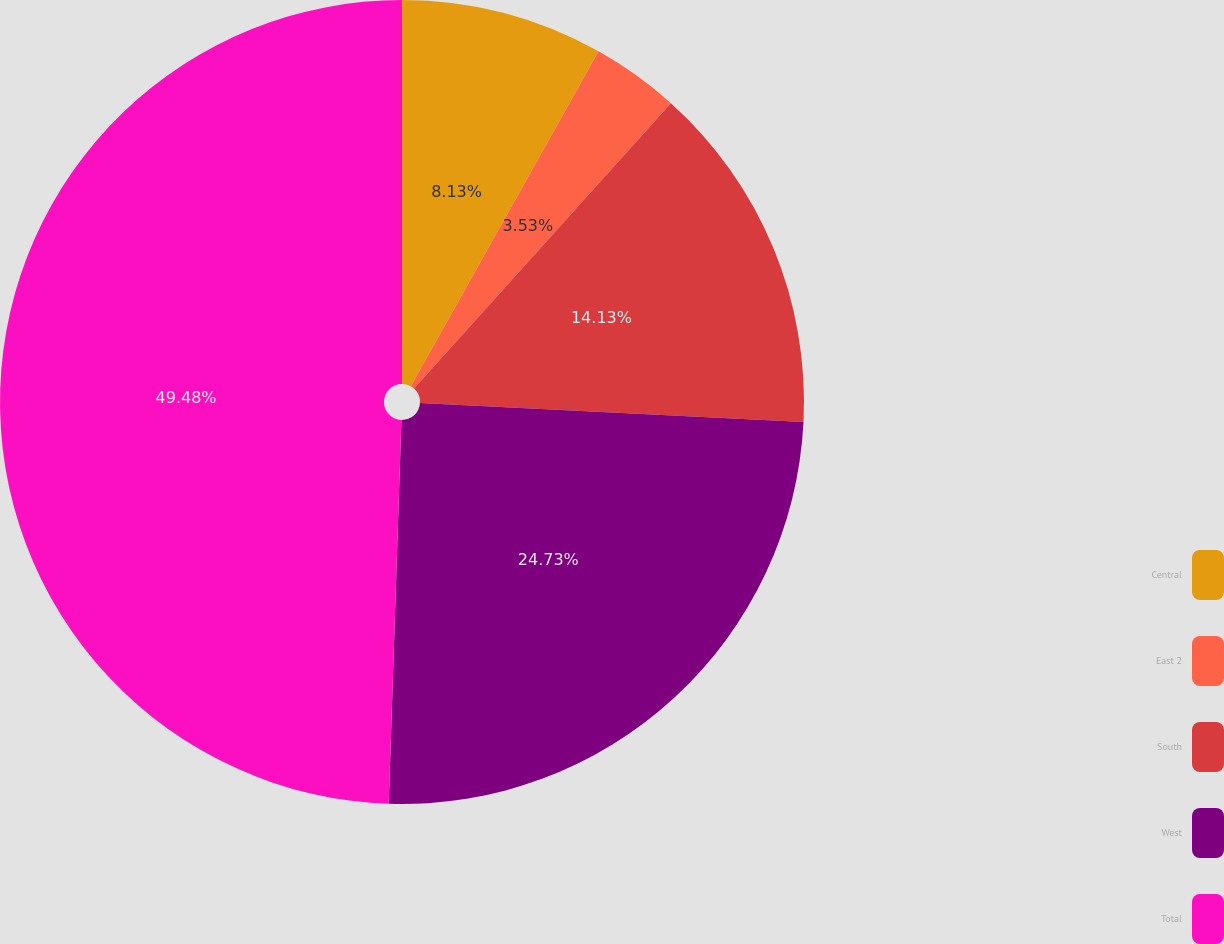Convert chart to OTSL. <chart><loc_0><loc_0><loc_500><loc_500><pie_chart><fcel>Central<fcel>East 2<fcel>South<fcel>West<fcel>Total<nl><fcel>8.13%<fcel>3.53%<fcel>14.13%<fcel>24.73%<fcel>49.47%<nl></chart> 